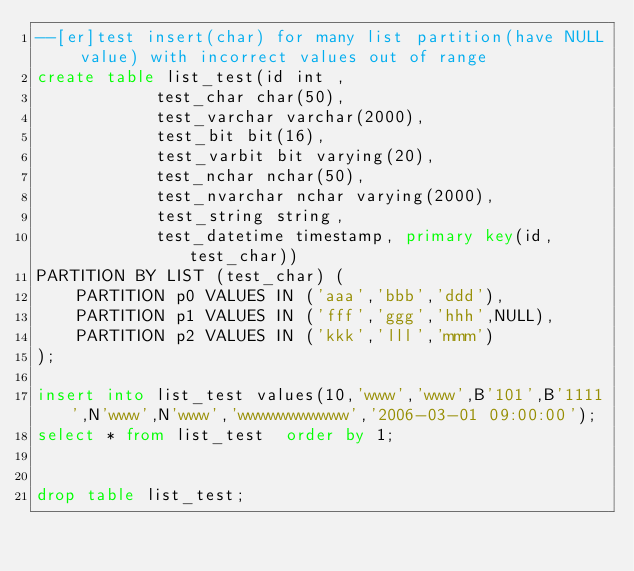<code> <loc_0><loc_0><loc_500><loc_500><_SQL_>--[er]test insert(char) for many list partition(have NULL value) with incorrect values out of range
create table list_test(id int ,      
			test_char char(50),               
			test_varchar varchar(2000),       
			test_bit bit(16),                 
			test_varbit bit varying(20),      
			test_nchar nchar(50),             
			test_nvarchar nchar varying(2000),
			test_string string,               
			test_datetime timestamp, primary key(id,test_char))          
PARTITION BY LIST (test_char) (                           
    PARTITION p0 VALUES IN ('aaa','bbb','ddd'),           
    PARTITION p1 VALUES IN ('fff','ggg','hhh',NULL),      
    PARTITION p2 VALUES IN ('kkk','lll','mmm')            
);                                                        

insert into list_test values(10,'www','www',B'101',B'1111',N'www',N'www','wwwwwwwwwww','2006-03-01 09:00:00');
select * from list_test  order by 1;


drop table list_test;
</code> 